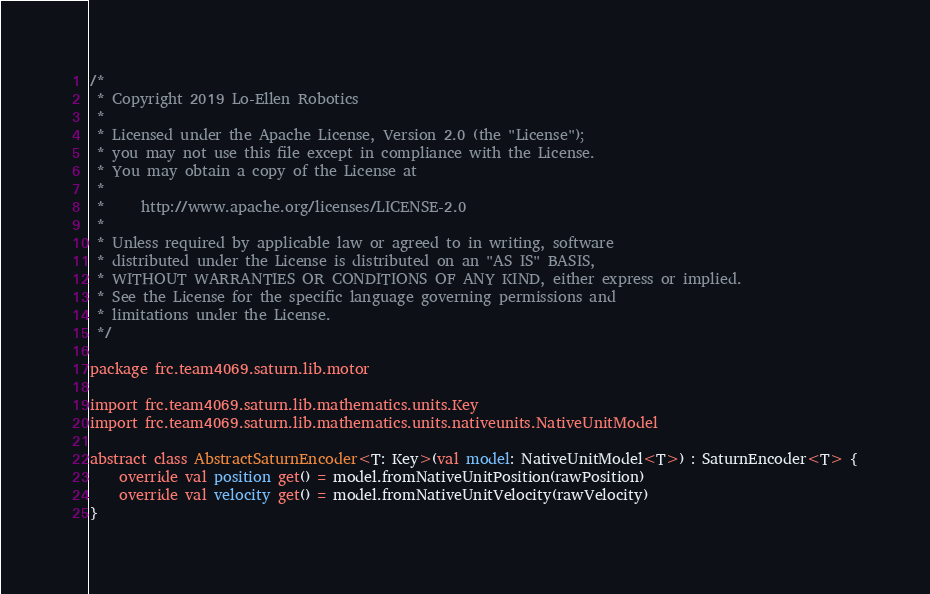Convert code to text. <code><loc_0><loc_0><loc_500><loc_500><_Kotlin_>/*
 * Copyright 2019 Lo-Ellen Robotics
 *
 * Licensed under the Apache License, Version 2.0 (the "License");
 * you may not use this file except in compliance with the License.
 * You may obtain a copy of the License at
 *
 *     http://www.apache.org/licenses/LICENSE-2.0
 *
 * Unless required by applicable law or agreed to in writing, software
 * distributed under the License is distributed on an "AS IS" BASIS,
 * WITHOUT WARRANTIES OR CONDITIONS OF ANY KIND, either express or implied.
 * See the License for the specific language governing permissions and
 * limitations under the License.
 */

package frc.team4069.saturn.lib.motor

import frc.team4069.saturn.lib.mathematics.units.Key
import frc.team4069.saturn.lib.mathematics.units.nativeunits.NativeUnitModel

abstract class AbstractSaturnEncoder<T: Key>(val model: NativeUnitModel<T>) : SaturnEncoder<T> {
    override val position get() = model.fromNativeUnitPosition(rawPosition)
    override val velocity get() = model.fromNativeUnitVelocity(rawVelocity)
}</code> 